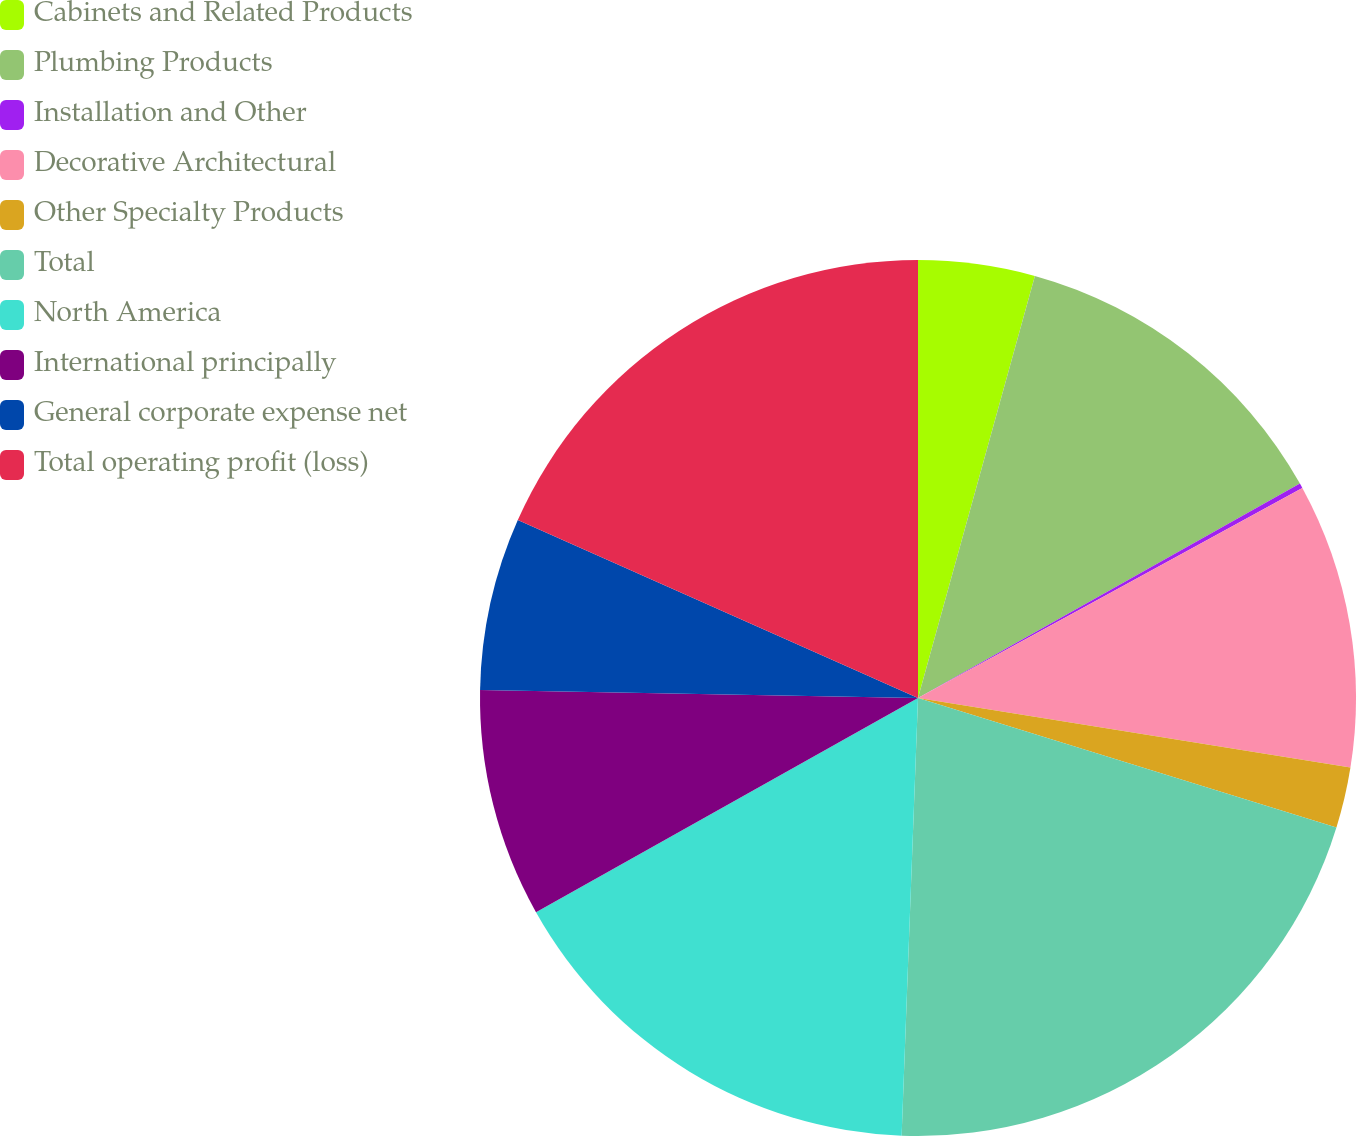Convert chart. <chart><loc_0><loc_0><loc_500><loc_500><pie_chart><fcel>Cabinets and Related Products<fcel>Plumbing Products<fcel>Installation and Other<fcel>Decorative Architectural<fcel>Other Specialty Products<fcel>Total<fcel>North America<fcel>International principally<fcel>General corporate expense net<fcel>Total operating profit (loss)<nl><fcel>4.3%<fcel>12.56%<fcel>0.18%<fcel>10.5%<fcel>2.24%<fcel>20.82%<fcel>16.27%<fcel>8.43%<fcel>6.37%<fcel>18.34%<nl></chart> 